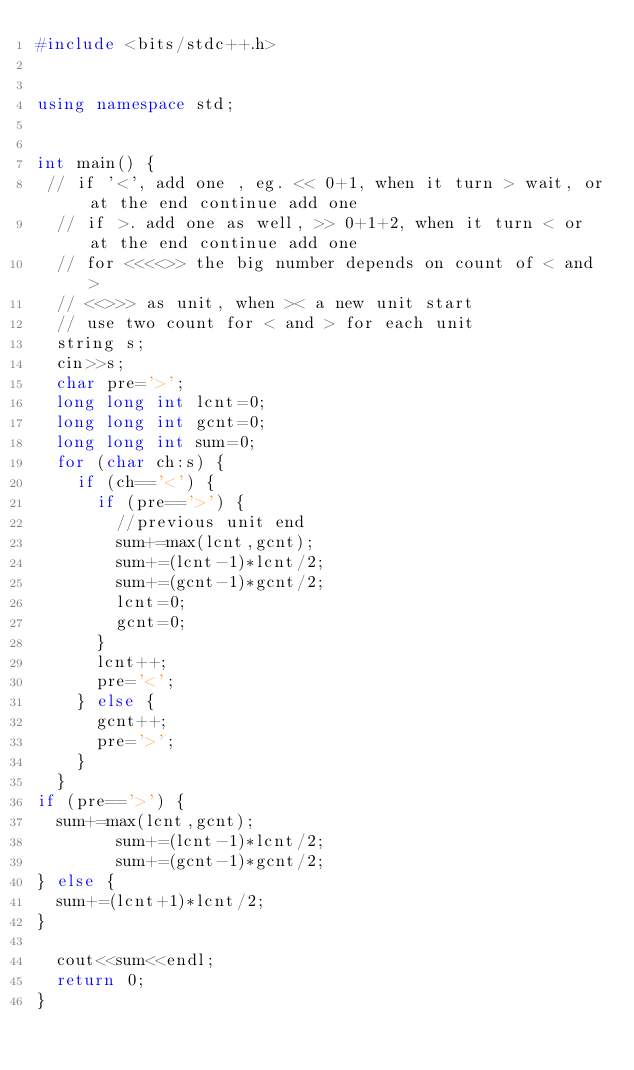<code> <loc_0><loc_0><loc_500><loc_500><_C++_>#include <bits/stdc++.h>


using namespace std;


int main() {
 // if '<', add one , eg. << 0+1, when it turn > wait, or at the end continue add one
  // if >. add one as well, >> 0+1+2, when it turn < or at the end continue add one
  // for <<<<>> the big number depends on count of < and >
  // <<>>> as unit, when >< a new unit start
  // use two count for < and > for each unit
  string s;
  cin>>s;
  char pre='>';
  long long int lcnt=0;
  long long int gcnt=0;
  long long int sum=0;
  for (char ch:s) {
    if (ch=='<') {
      if (pre=='>') {
        //previous unit end
        sum+=max(lcnt,gcnt);
        sum+=(lcnt-1)*lcnt/2;
        sum+=(gcnt-1)*gcnt/2;
        lcnt=0;
        gcnt=0;        
      }
      lcnt++;
      pre='<';
    } else {
      gcnt++;
      pre='>';
    }
  }
if (pre=='>') {
  sum+=max(lcnt,gcnt);
        sum+=(lcnt-1)*lcnt/2;
        sum+=(gcnt-1)*gcnt/2;
} else {
  sum+=(lcnt+1)*lcnt/2;
}
  
  cout<<sum<<endl;
  return 0;
}</code> 